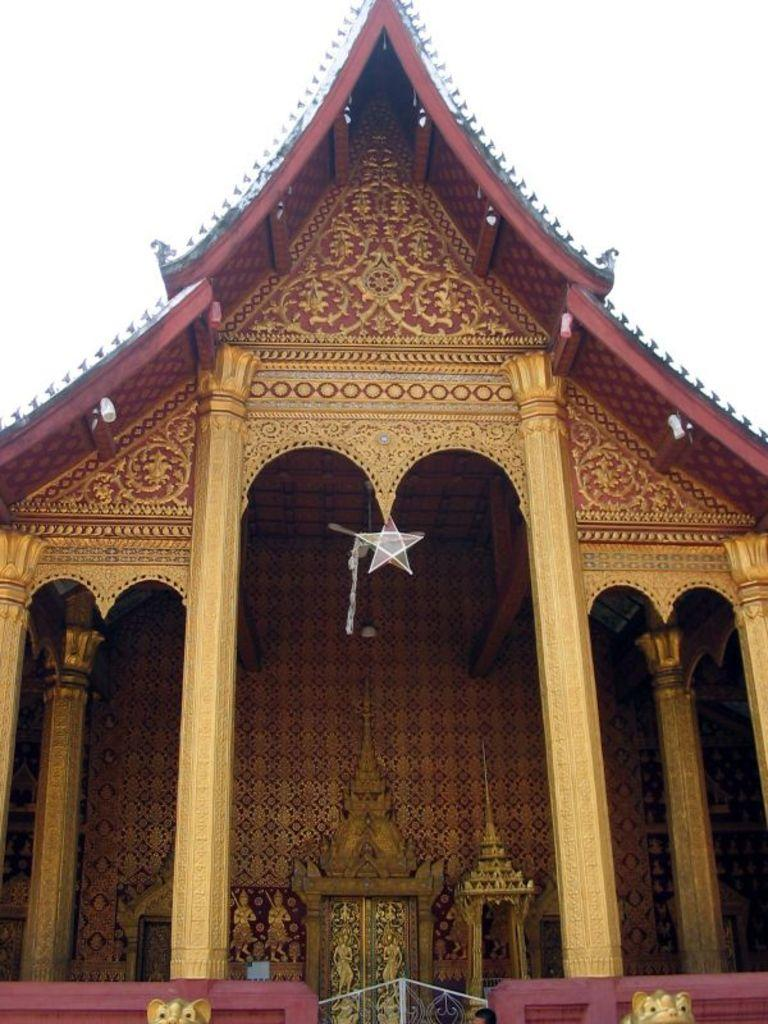What type of structure is visible in the image? There is a house in the image. What can be seen on the house? There are lights and a star on the house. What other objects are present in the image? There are golden statues ines in the image. What type of beast can be seen wearing trousers in the image? There is no beast or trousers present in the image. Is there a club visible in the image? There is no club present in the image. 